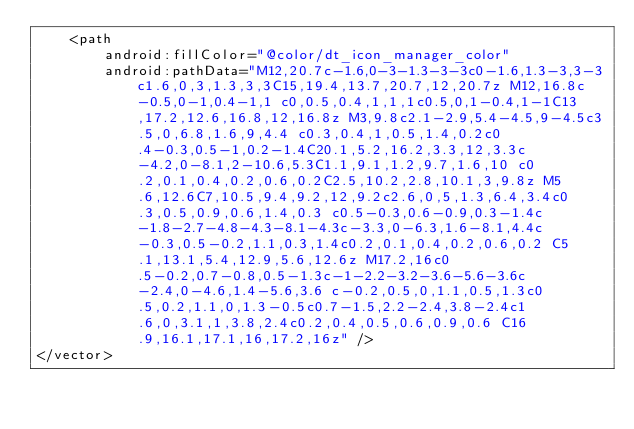Convert code to text. <code><loc_0><loc_0><loc_500><loc_500><_XML_>    <path
        android:fillColor="@color/dt_icon_manager_color"
        android:pathData="M12,20.7c-1.6,0-3-1.3-3-3c0-1.6,1.3-3,3-3c1.6,0,3,1.3,3,3C15,19.4,13.7,20.7,12,20.7z M12,16.8c-0.5,0-1,0.4-1,1 c0,0.5,0.4,1,1,1c0.5,0,1-0.4,1-1C13,17.2,12.6,16.8,12,16.8z M3,9.8c2.1-2.9,5.4-4.5,9-4.5c3.5,0,6.8,1.6,9,4.4 c0.3,0.4,1,0.5,1.4,0.2c0.4-0.3,0.5-1,0.2-1.4C20.1,5.2,16.2,3.3,12,3.3c-4.2,0-8.1,2-10.6,5.3C1.1,9.1,1.2,9.7,1.6,10 c0.2,0.1,0.4,0.2,0.6,0.2C2.5,10.2,2.8,10.1,3,9.8z M5.6,12.6C7,10.5,9.4,9.2,12,9.2c2.6,0,5,1.3,6.4,3.4c0.3,0.5,0.9,0.6,1.4,0.3 c0.5-0.3,0.6-0.9,0.3-1.4c-1.8-2.7-4.8-4.3-8.1-4.3c-3.3,0-6.3,1.6-8.1,4.4c-0.3,0.5-0.2,1.1,0.3,1.4c0.2,0.1,0.4,0.2,0.6,0.2 C5.1,13.1,5.4,12.9,5.6,12.6z M17.2,16c0.5-0.2,0.7-0.8,0.5-1.3c-1-2.2-3.2-3.6-5.6-3.6c-2.4,0-4.6,1.4-5.6,3.6 c-0.2,0.5,0,1.1,0.5,1.3c0.5,0.2,1.1,0,1.3-0.5c0.7-1.5,2.2-2.4,3.8-2.4c1.6,0,3.1,1,3.8,2.4c0.2,0.4,0.5,0.6,0.9,0.6 C16.9,16.1,17.1,16,17.2,16z" />
</vector>
</code> 